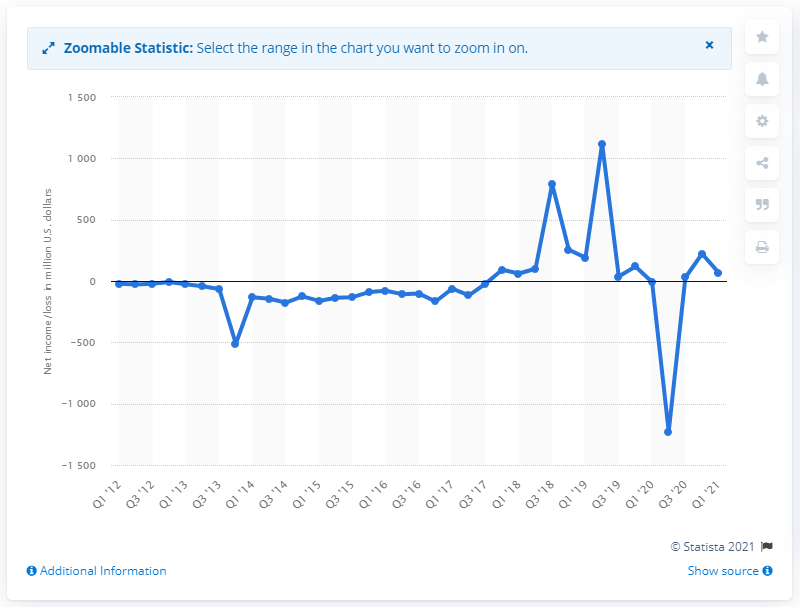Indicate a few pertinent items in this graphic. Twitter's net income in the last quarter was 68.01. 